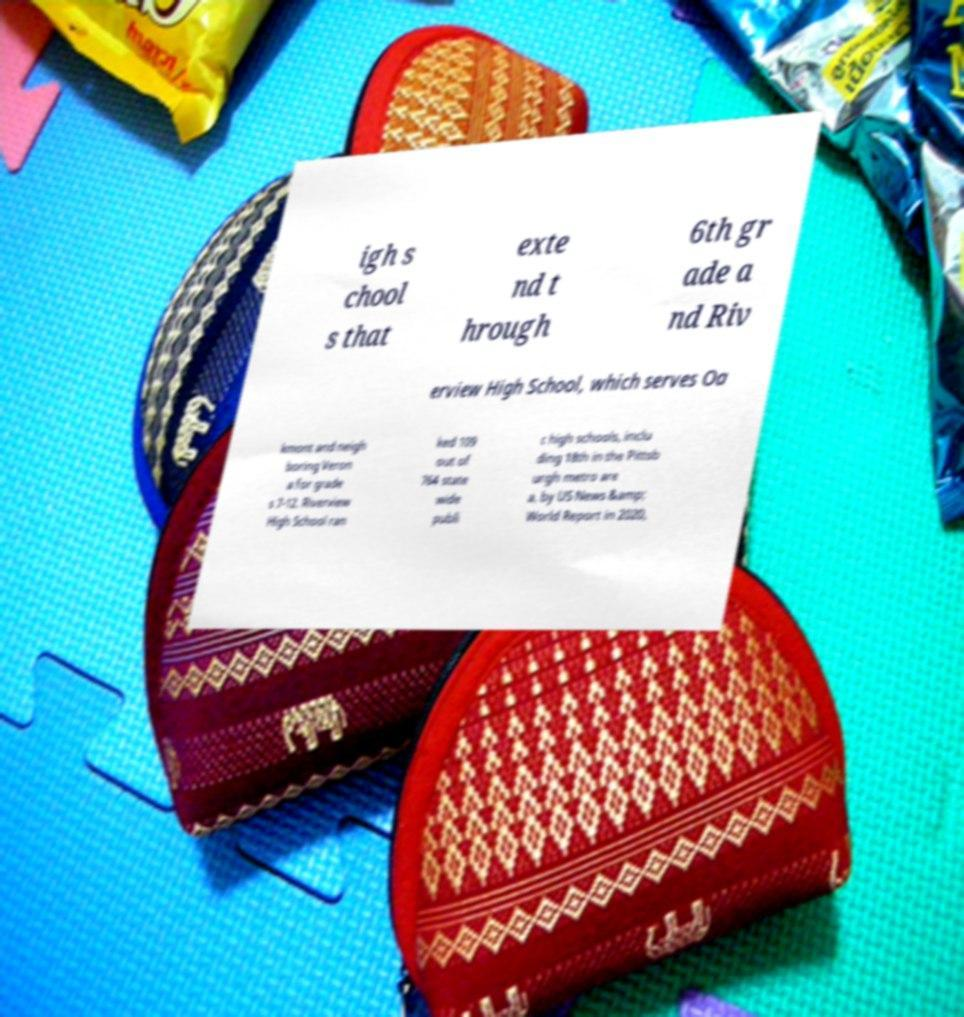Please identify and transcribe the text found in this image. igh s chool s that exte nd t hrough 6th gr ade a nd Riv erview High School, which serves Oa kmont and neigh boring Veron a for grade s 7-12. Riverview High School ran ked 109 out of 764 state wide publi c high schools, inclu ding 18th in the Pittsb urgh metro are a, by US News &amp; World Report in 2020, 